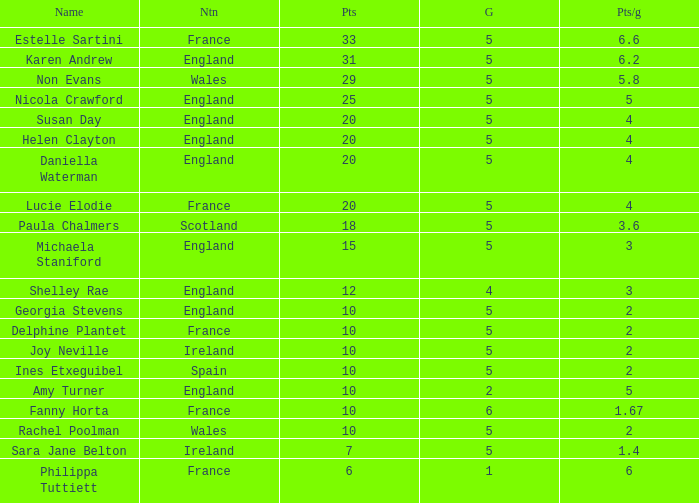Can you tell me the lowest Pts/game that has the Name of philippa tuttiett, and the Points larger then 6? None. 